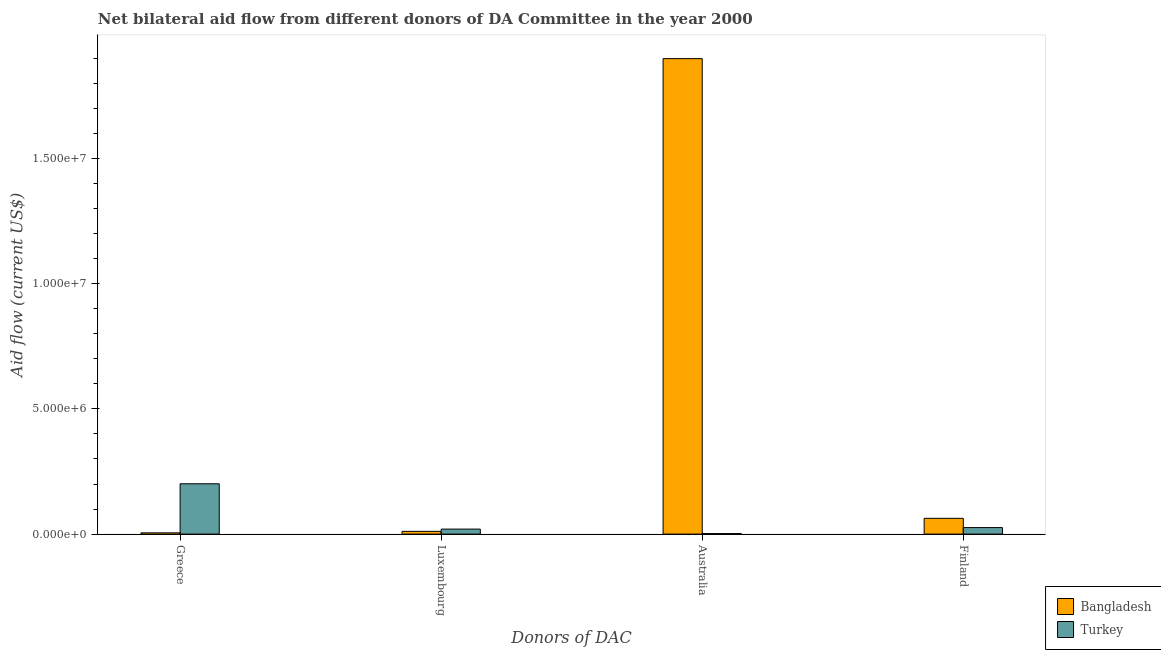Are the number of bars per tick equal to the number of legend labels?
Give a very brief answer. Yes. How many bars are there on the 2nd tick from the right?
Your answer should be very brief. 2. What is the amount of aid given by finland in Bangladesh?
Your answer should be compact. 6.30e+05. Across all countries, what is the maximum amount of aid given by luxembourg?
Your response must be concise. 2.00e+05. Across all countries, what is the minimum amount of aid given by luxembourg?
Provide a succinct answer. 1.10e+05. In which country was the amount of aid given by luxembourg minimum?
Provide a short and direct response. Bangladesh. What is the total amount of aid given by luxembourg in the graph?
Ensure brevity in your answer.  3.10e+05. What is the difference between the amount of aid given by australia in Turkey and that in Bangladesh?
Provide a short and direct response. -1.90e+07. What is the difference between the amount of aid given by finland in Bangladesh and the amount of aid given by luxembourg in Turkey?
Offer a terse response. 4.30e+05. What is the average amount of aid given by luxembourg per country?
Offer a terse response. 1.55e+05. What is the difference between the amount of aid given by luxembourg and amount of aid given by finland in Turkey?
Ensure brevity in your answer.  -6.00e+04. What is the ratio of the amount of aid given by finland in Bangladesh to that in Turkey?
Your answer should be very brief. 2.42. Is the amount of aid given by greece in Turkey less than that in Bangladesh?
Provide a short and direct response. No. Is the difference between the amount of aid given by luxembourg in Bangladesh and Turkey greater than the difference between the amount of aid given by australia in Bangladesh and Turkey?
Ensure brevity in your answer.  No. What is the difference between the highest and the second highest amount of aid given by greece?
Your response must be concise. 1.96e+06. What is the difference between the highest and the lowest amount of aid given by luxembourg?
Your response must be concise. 9.00e+04. How many bars are there?
Offer a very short reply. 8. What is the difference between two consecutive major ticks on the Y-axis?
Give a very brief answer. 5.00e+06. How many legend labels are there?
Offer a very short reply. 2. How are the legend labels stacked?
Ensure brevity in your answer.  Vertical. What is the title of the graph?
Your response must be concise. Net bilateral aid flow from different donors of DA Committee in the year 2000. Does "Czech Republic" appear as one of the legend labels in the graph?
Offer a terse response. No. What is the label or title of the X-axis?
Offer a terse response. Donors of DAC. What is the Aid flow (current US$) in Bangladesh in Greece?
Give a very brief answer. 5.00e+04. What is the Aid flow (current US$) of Turkey in Greece?
Keep it short and to the point. 2.01e+06. What is the Aid flow (current US$) in Bangladesh in Luxembourg?
Your answer should be compact. 1.10e+05. What is the Aid flow (current US$) in Turkey in Luxembourg?
Offer a very short reply. 2.00e+05. What is the Aid flow (current US$) in Bangladesh in Australia?
Offer a terse response. 1.90e+07. What is the Aid flow (current US$) of Turkey in Australia?
Provide a short and direct response. 2.00e+04. What is the Aid flow (current US$) of Bangladesh in Finland?
Provide a succinct answer. 6.30e+05. Across all Donors of DAC, what is the maximum Aid flow (current US$) in Bangladesh?
Offer a very short reply. 1.90e+07. Across all Donors of DAC, what is the maximum Aid flow (current US$) of Turkey?
Ensure brevity in your answer.  2.01e+06. What is the total Aid flow (current US$) of Bangladesh in the graph?
Make the answer very short. 1.98e+07. What is the total Aid flow (current US$) in Turkey in the graph?
Offer a very short reply. 2.49e+06. What is the difference between the Aid flow (current US$) in Turkey in Greece and that in Luxembourg?
Provide a short and direct response. 1.81e+06. What is the difference between the Aid flow (current US$) of Bangladesh in Greece and that in Australia?
Provide a short and direct response. -1.89e+07. What is the difference between the Aid flow (current US$) in Turkey in Greece and that in Australia?
Provide a short and direct response. 1.99e+06. What is the difference between the Aid flow (current US$) of Bangladesh in Greece and that in Finland?
Offer a very short reply. -5.80e+05. What is the difference between the Aid flow (current US$) of Turkey in Greece and that in Finland?
Offer a terse response. 1.75e+06. What is the difference between the Aid flow (current US$) of Bangladesh in Luxembourg and that in Australia?
Your answer should be very brief. -1.89e+07. What is the difference between the Aid flow (current US$) of Turkey in Luxembourg and that in Australia?
Offer a very short reply. 1.80e+05. What is the difference between the Aid flow (current US$) in Bangladesh in Luxembourg and that in Finland?
Your answer should be compact. -5.20e+05. What is the difference between the Aid flow (current US$) in Turkey in Luxembourg and that in Finland?
Provide a short and direct response. -6.00e+04. What is the difference between the Aid flow (current US$) of Bangladesh in Australia and that in Finland?
Your answer should be compact. 1.84e+07. What is the difference between the Aid flow (current US$) of Turkey in Australia and that in Finland?
Offer a very short reply. -2.40e+05. What is the difference between the Aid flow (current US$) in Bangladesh in Greece and the Aid flow (current US$) in Turkey in Luxembourg?
Your response must be concise. -1.50e+05. What is the difference between the Aid flow (current US$) of Bangladesh in Luxembourg and the Aid flow (current US$) of Turkey in Australia?
Offer a very short reply. 9.00e+04. What is the difference between the Aid flow (current US$) of Bangladesh in Luxembourg and the Aid flow (current US$) of Turkey in Finland?
Give a very brief answer. -1.50e+05. What is the difference between the Aid flow (current US$) of Bangladesh in Australia and the Aid flow (current US$) of Turkey in Finland?
Ensure brevity in your answer.  1.87e+07. What is the average Aid flow (current US$) in Bangladesh per Donors of DAC?
Your answer should be compact. 4.94e+06. What is the average Aid flow (current US$) of Turkey per Donors of DAC?
Ensure brevity in your answer.  6.22e+05. What is the difference between the Aid flow (current US$) in Bangladesh and Aid flow (current US$) in Turkey in Greece?
Your response must be concise. -1.96e+06. What is the difference between the Aid flow (current US$) of Bangladesh and Aid flow (current US$) of Turkey in Luxembourg?
Give a very brief answer. -9.00e+04. What is the difference between the Aid flow (current US$) of Bangladesh and Aid flow (current US$) of Turkey in Australia?
Offer a very short reply. 1.90e+07. What is the ratio of the Aid flow (current US$) of Bangladesh in Greece to that in Luxembourg?
Offer a terse response. 0.45. What is the ratio of the Aid flow (current US$) of Turkey in Greece to that in Luxembourg?
Provide a succinct answer. 10.05. What is the ratio of the Aid flow (current US$) of Bangladesh in Greece to that in Australia?
Provide a succinct answer. 0. What is the ratio of the Aid flow (current US$) in Turkey in Greece to that in Australia?
Make the answer very short. 100.5. What is the ratio of the Aid flow (current US$) in Bangladesh in Greece to that in Finland?
Provide a short and direct response. 0.08. What is the ratio of the Aid flow (current US$) of Turkey in Greece to that in Finland?
Your answer should be compact. 7.73. What is the ratio of the Aid flow (current US$) in Bangladesh in Luxembourg to that in Australia?
Your answer should be very brief. 0.01. What is the ratio of the Aid flow (current US$) in Turkey in Luxembourg to that in Australia?
Provide a short and direct response. 10. What is the ratio of the Aid flow (current US$) of Bangladesh in Luxembourg to that in Finland?
Offer a terse response. 0.17. What is the ratio of the Aid flow (current US$) of Turkey in Luxembourg to that in Finland?
Provide a succinct answer. 0.77. What is the ratio of the Aid flow (current US$) in Bangladesh in Australia to that in Finland?
Provide a short and direct response. 30.14. What is the ratio of the Aid flow (current US$) of Turkey in Australia to that in Finland?
Keep it short and to the point. 0.08. What is the difference between the highest and the second highest Aid flow (current US$) in Bangladesh?
Give a very brief answer. 1.84e+07. What is the difference between the highest and the second highest Aid flow (current US$) of Turkey?
Offer a very short reply. 1.75e+06. What is the difference between the highest and the lowest Aid flow (current US$) in Bangladesh?
Ensure brevity in your answer.  1.89e+07. What is the difference between the highest and the lowest Aid flow (current US$) in Turkey?
Provide a short and direct response. 1.99e+06. 